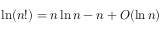Convert formula to latex. <formula><loc_0><loc_0><loc_500><loc_500>\ln ( n ! ) = n \ln n - n + O ( \ln n )</formula> 